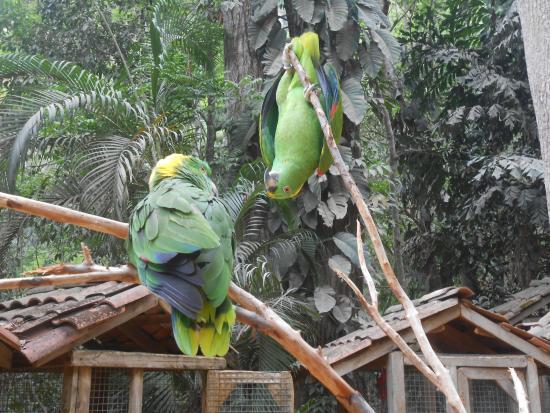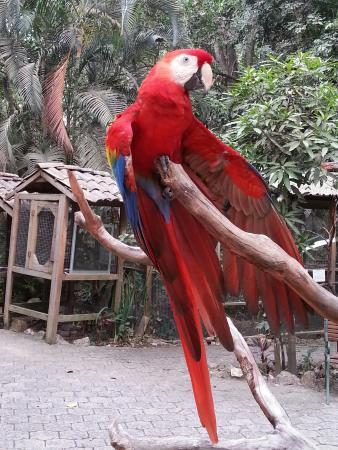The first image is the image on the left, the second image is the image on the right. For the images displayed, is the sentence "The image on the right contains only one parrot." factually correct? Answer yes or no. Yes. The first image is the image on the left, the second image is the image on the right. Considering the images on both sides, is "One of the images contains parrots of different colors." valid? Answer yes or no. No. 